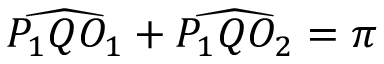Convert formula to latex. <formula><loc_0><loc_0><loc_500><loc_500>{ \widehat { P _ { 1 } Q O _ { 1 } } } + { \widehat { P _ { 1 } Q O _ { 2 } } } = \pi</formula> 